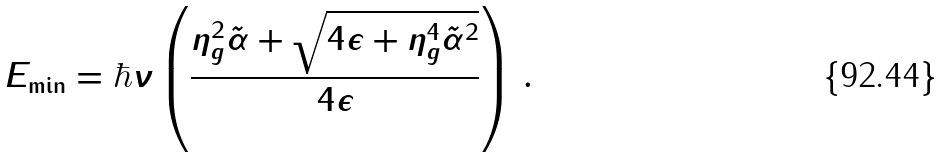Convert formula to latex. <formula><loc_0><loc_0><loc_500><loc_500>E _ { \min } = \hbar { \nu } \left ( \frac { \eta _ { g } ^ { 2 } \tilde { \alpha } + \sqrt { 4 \epsilon + \eta _ { g } ^ { 4 } \tilde { \alpha } ^ { 2 } } } { 4 \epsilon } \right ) \, .</formula> 